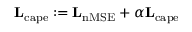<formula> <loc_0><loc_0><loc_500><loc_500>L _ { c a p e } \colon = L _ { n M S E } + \alpha L _ { c a p e }</formula> 